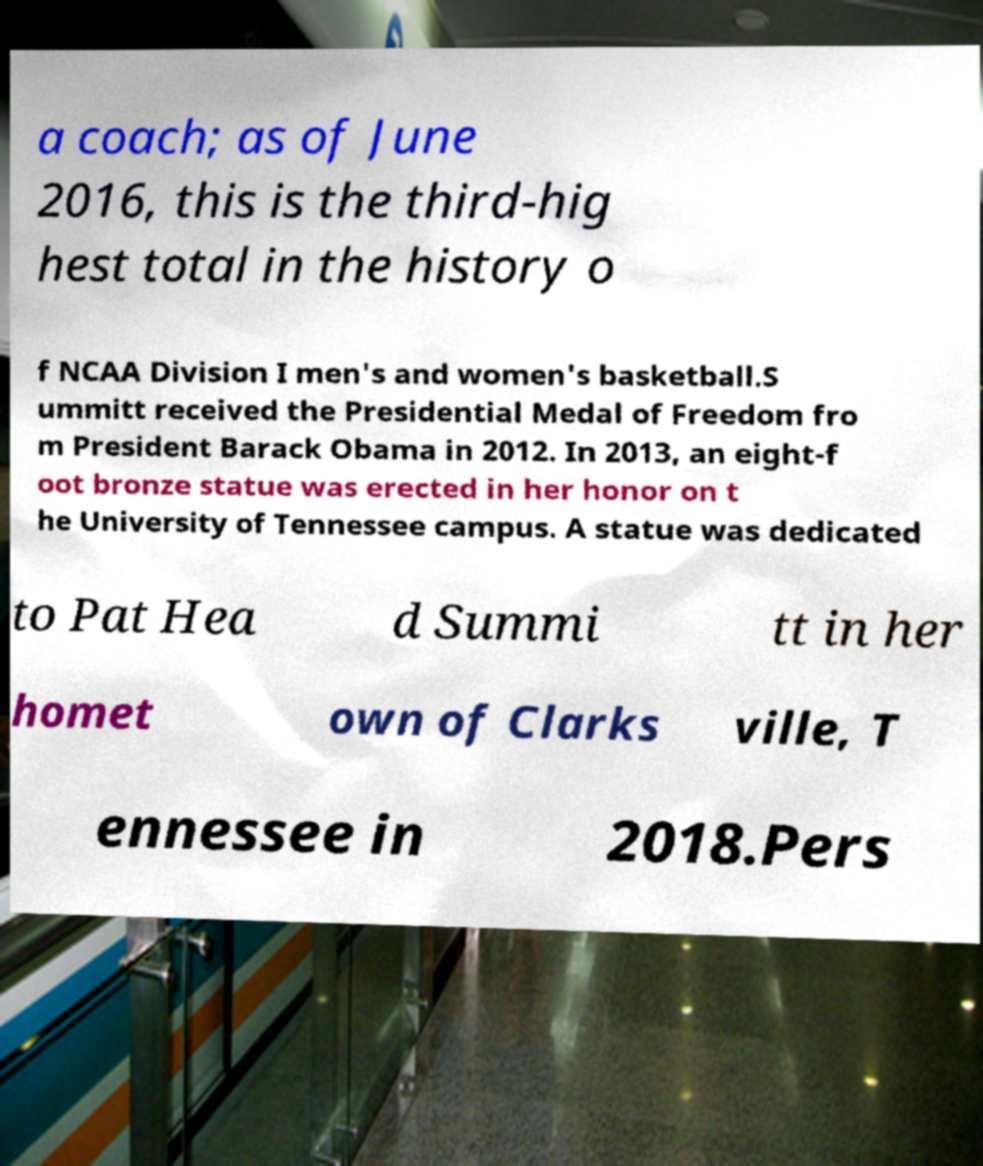Can you accurately transcribe the text from the provided image for me? a coach; as of June 2016, this is the third-hig hest total in the history o f NCAA Division I men's and women's basketball.S ummitt received the Presidential Medal of Freedom fro m President Barack Obama in 2012. In 2013, an eight-f oot bronze statue was erected in her honor on t he University of Tennessee campus. A statue was dedicated to Pat Hea d Summi tt in her homet own of Clarks ville, T ennessee in 2018.Pers 